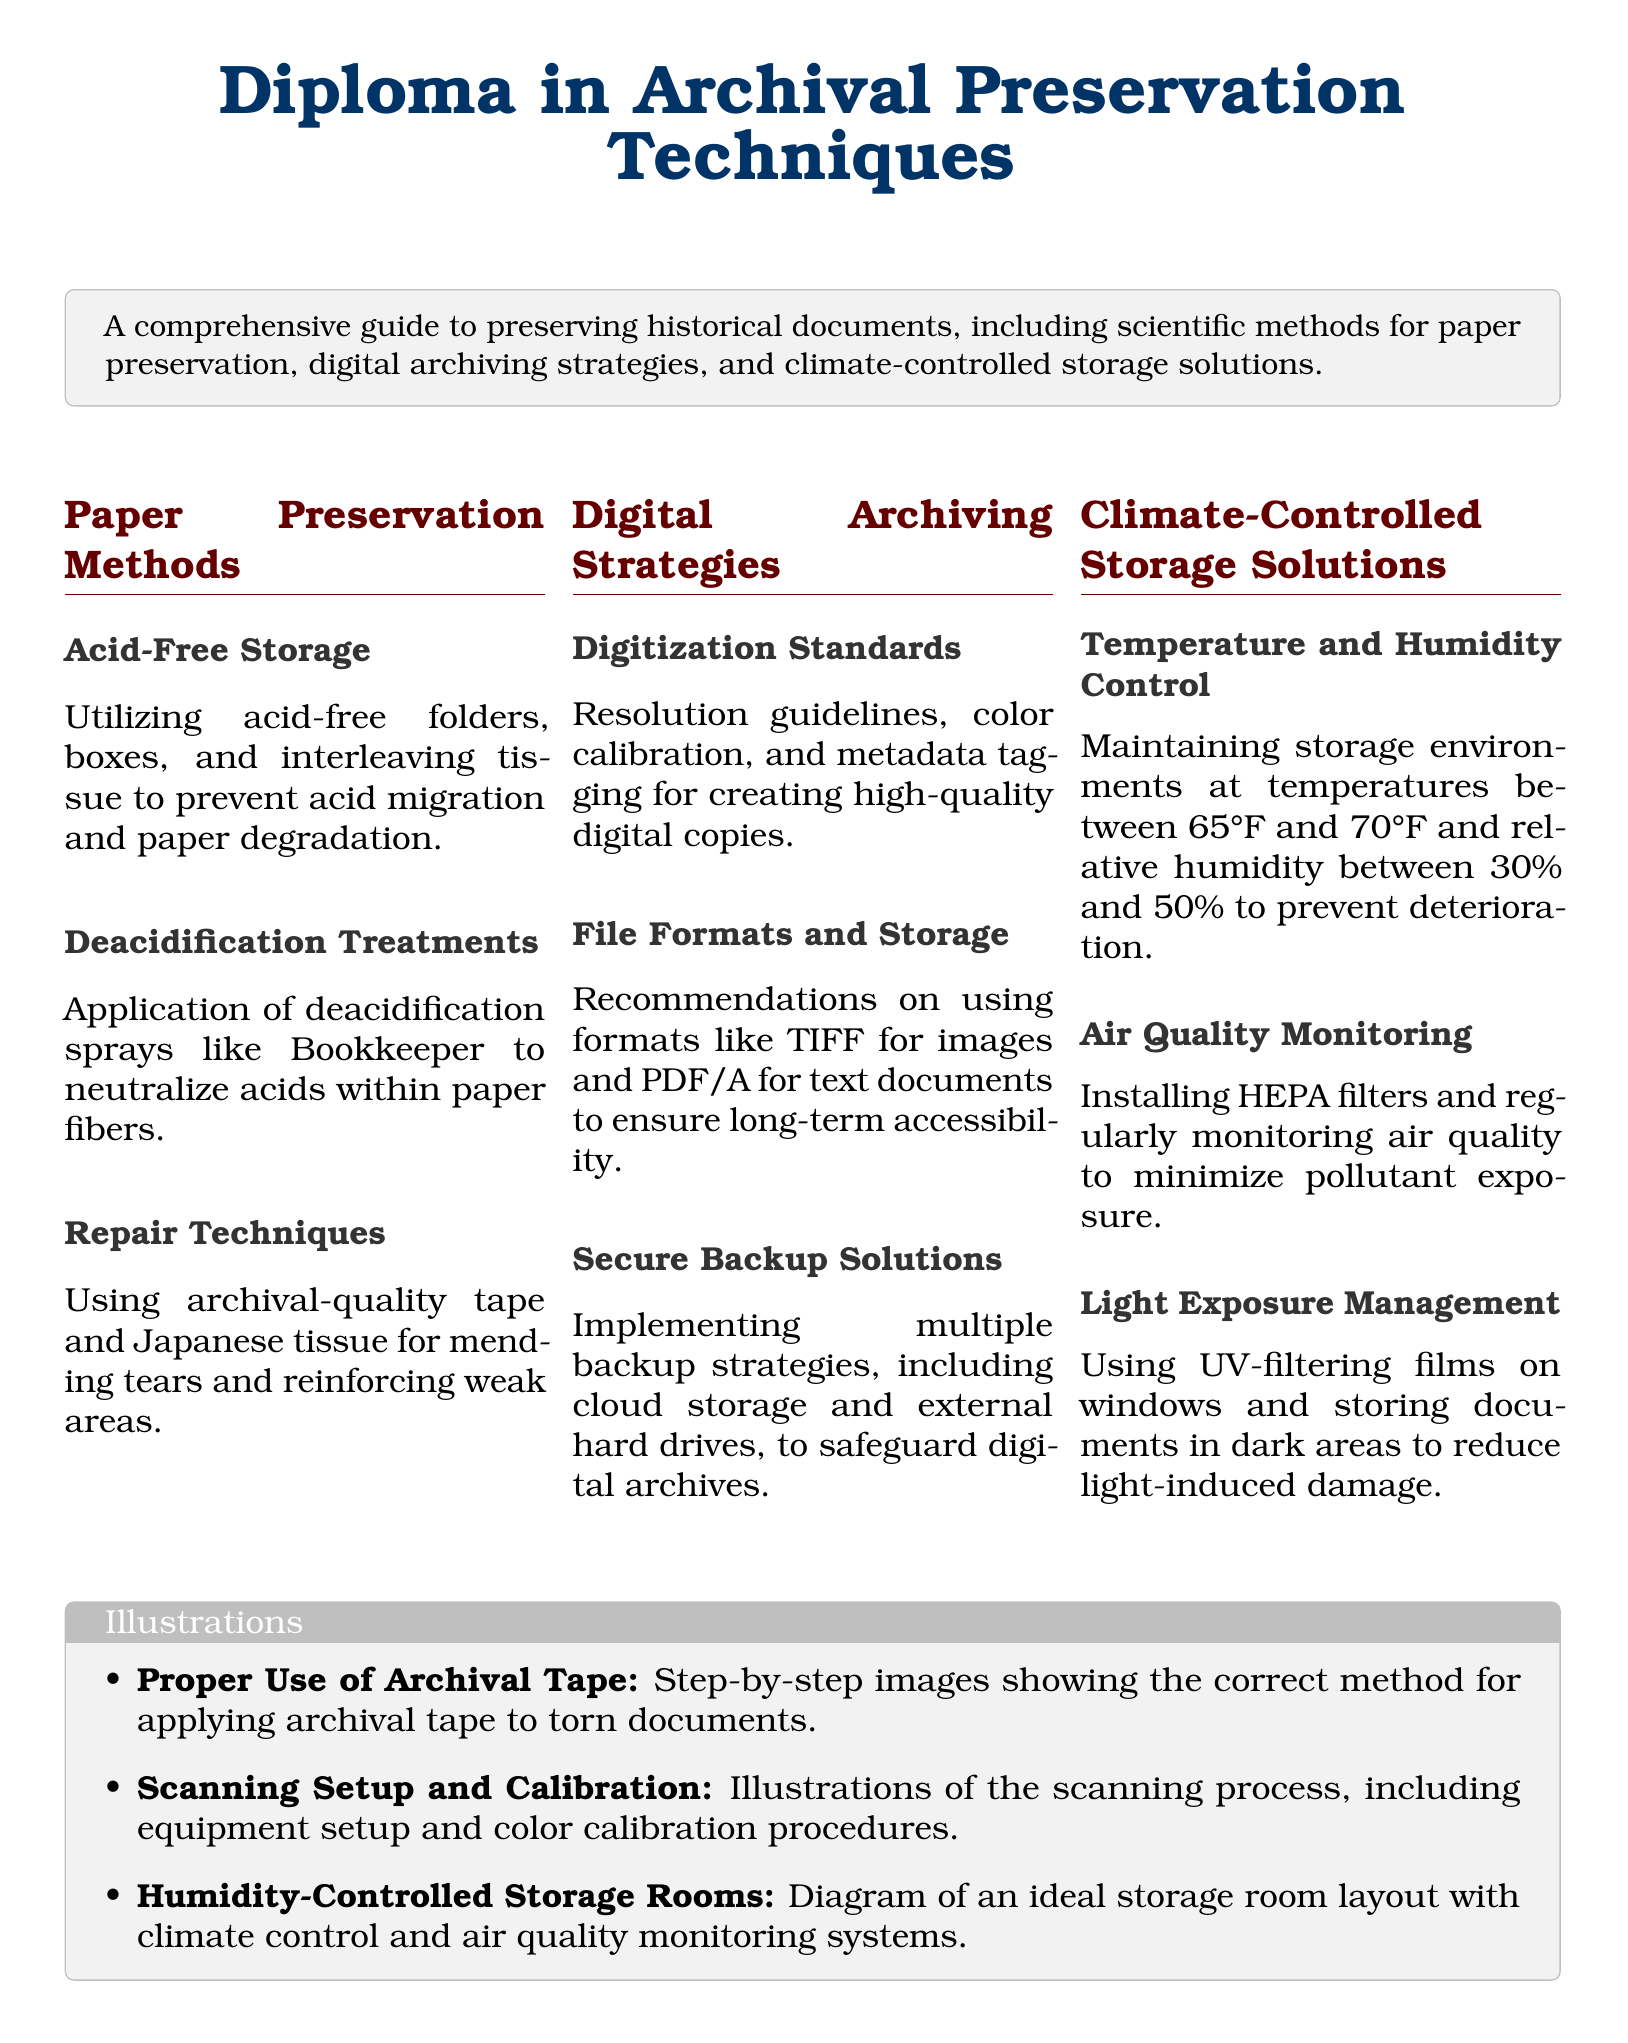What is the title of the diploma? The title of the diploma is explicitly mentioned at the beginning of the document.
Answer: Diploma in Archival Preservation Techniques What is the recommended temperature range for climate-controlled storage? The document specifies the ideal temperature range to prevent document deterioration.
Answer: 65°F to 70°F Which archival treatment neutralizes acids in paper? The document outlines specific methods for preserving documents, including deacidification treatments.
Answer: Deacidification treatments What type of illustrations are included for proper repair techniques? The types of illustrations mentioned provide guidance on specific archival methods.
Answer: Proper Use of Archival Tape What file format is recommended for text documents in digital archiving? The document specifies preferred formats for archiving to ensure long-term accessibility.
Answer: PDF/A What humidity level should be maintained in storage environments? The document details the relative humidity levels necessary for document preservation.
Answer: 30% to 50% What kind of filters should be installed for air quality monitoring? The document mentions specific filters that help maintain air quality in storage rooms.
Answer: HEPA filters What method is used for mending tears in documents? The document lists techniques for repairing damaged documents.
Answer: Archival-quality tape and Japanese tissue 